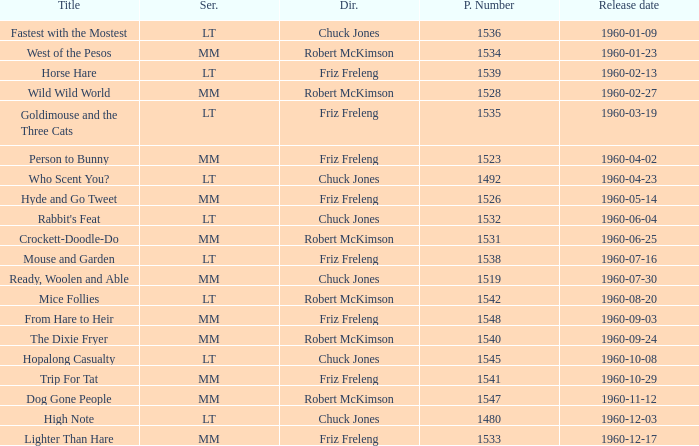What is the production number of From Hare to Heir? 1548.0. 